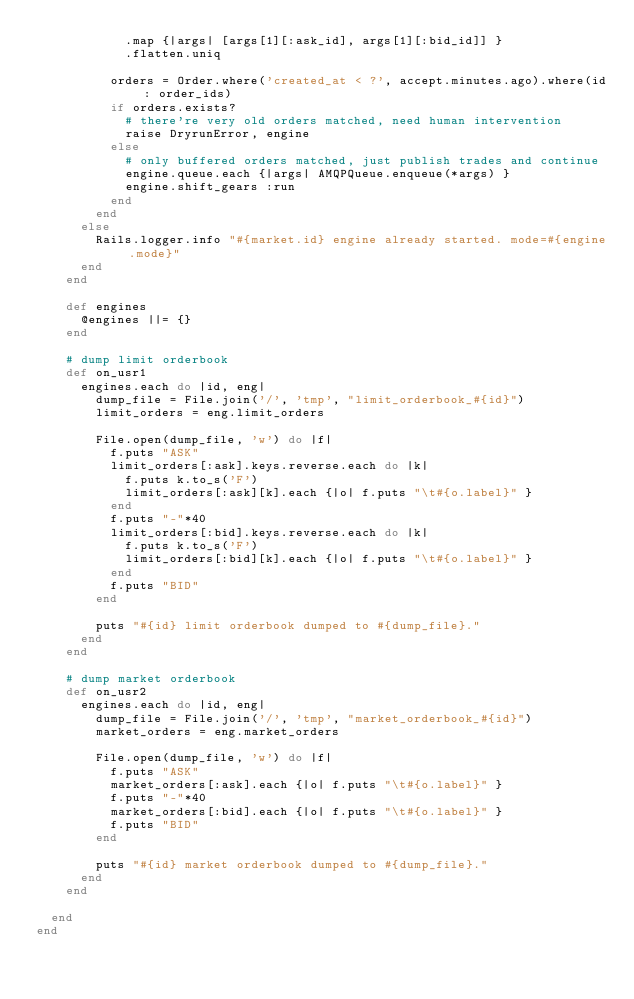<code> <loc_0><loc_0><loc_500><loc_500><_Ruby_>            .map {|args| [args[1][:ask_id], args[1][:bid_id]] }
            .flatten.uniq

          orders = Order.where('created_at < ?', accept.minutes.ago).where(id: order_ids)
          if orders.exists?
            # there're very old orders matched, need human intervention
            raise DryrunError, engine
          else
            # only buffered orders matched, just publish trades and continue
            engine.queue.each {|args| AMQPQueue.enqueue(*args) }
            engine.shift_gears :run
          end
        end
      else
        Rails.logger.info "#{market.id} engine already started. mode=#{engine.mode}"
      end
    end

    def engines
      @engines ||= {}
    end

    # dump limit orderbook
    def on_usr1
      engines.each do |id, eng|
        dump_file = File.join('/', 'tmp', "limit_orderbook_#{id}")
        limit_orders = eng.limit_orders

        File.open(dump_file, 'w') do |f|
          f.puts "ASK"
          limit_orders[:ask].keys.reverse.each do |k|
            f.puts k.to_s('F')
            limit_orders[:ask][k].each {|o| f.puts "\t#{o.label}" }
          end
          f.puts "-"*40
          limit_orders[:bid].keys.reverse.each do |k|
            f.puts k.to_s('F')
            limit_orders[:bid][k].each {|o| f.puts "\t#{o.label}" }
          end
          f.puts "BID"
        end

        puts "#{id} limit orderbook dumped to #{dump_file}."
      end
    end

    # dump market orderbook
    def on_usr2
      engines.each do |id, eng|
        dump_file = File.join('/', 'tmp', "market_orderbook_#{id}")
        market_orders = eng.market_orders

        File.open(dump_file, 'w') do |f|
          f.puts "ASK"
          market_orders[:ask].each {|o| f.puts "\t#{o.label}" }
          f.puts "-"*40
          market_orders[:bid].each {|o| f.puts "\t#{o.label}" }
          f.puts "BID"
        end

        puts "#{id} market orderbook dumped to #{dump_file}."
      end
    end

  end
end
</code> 